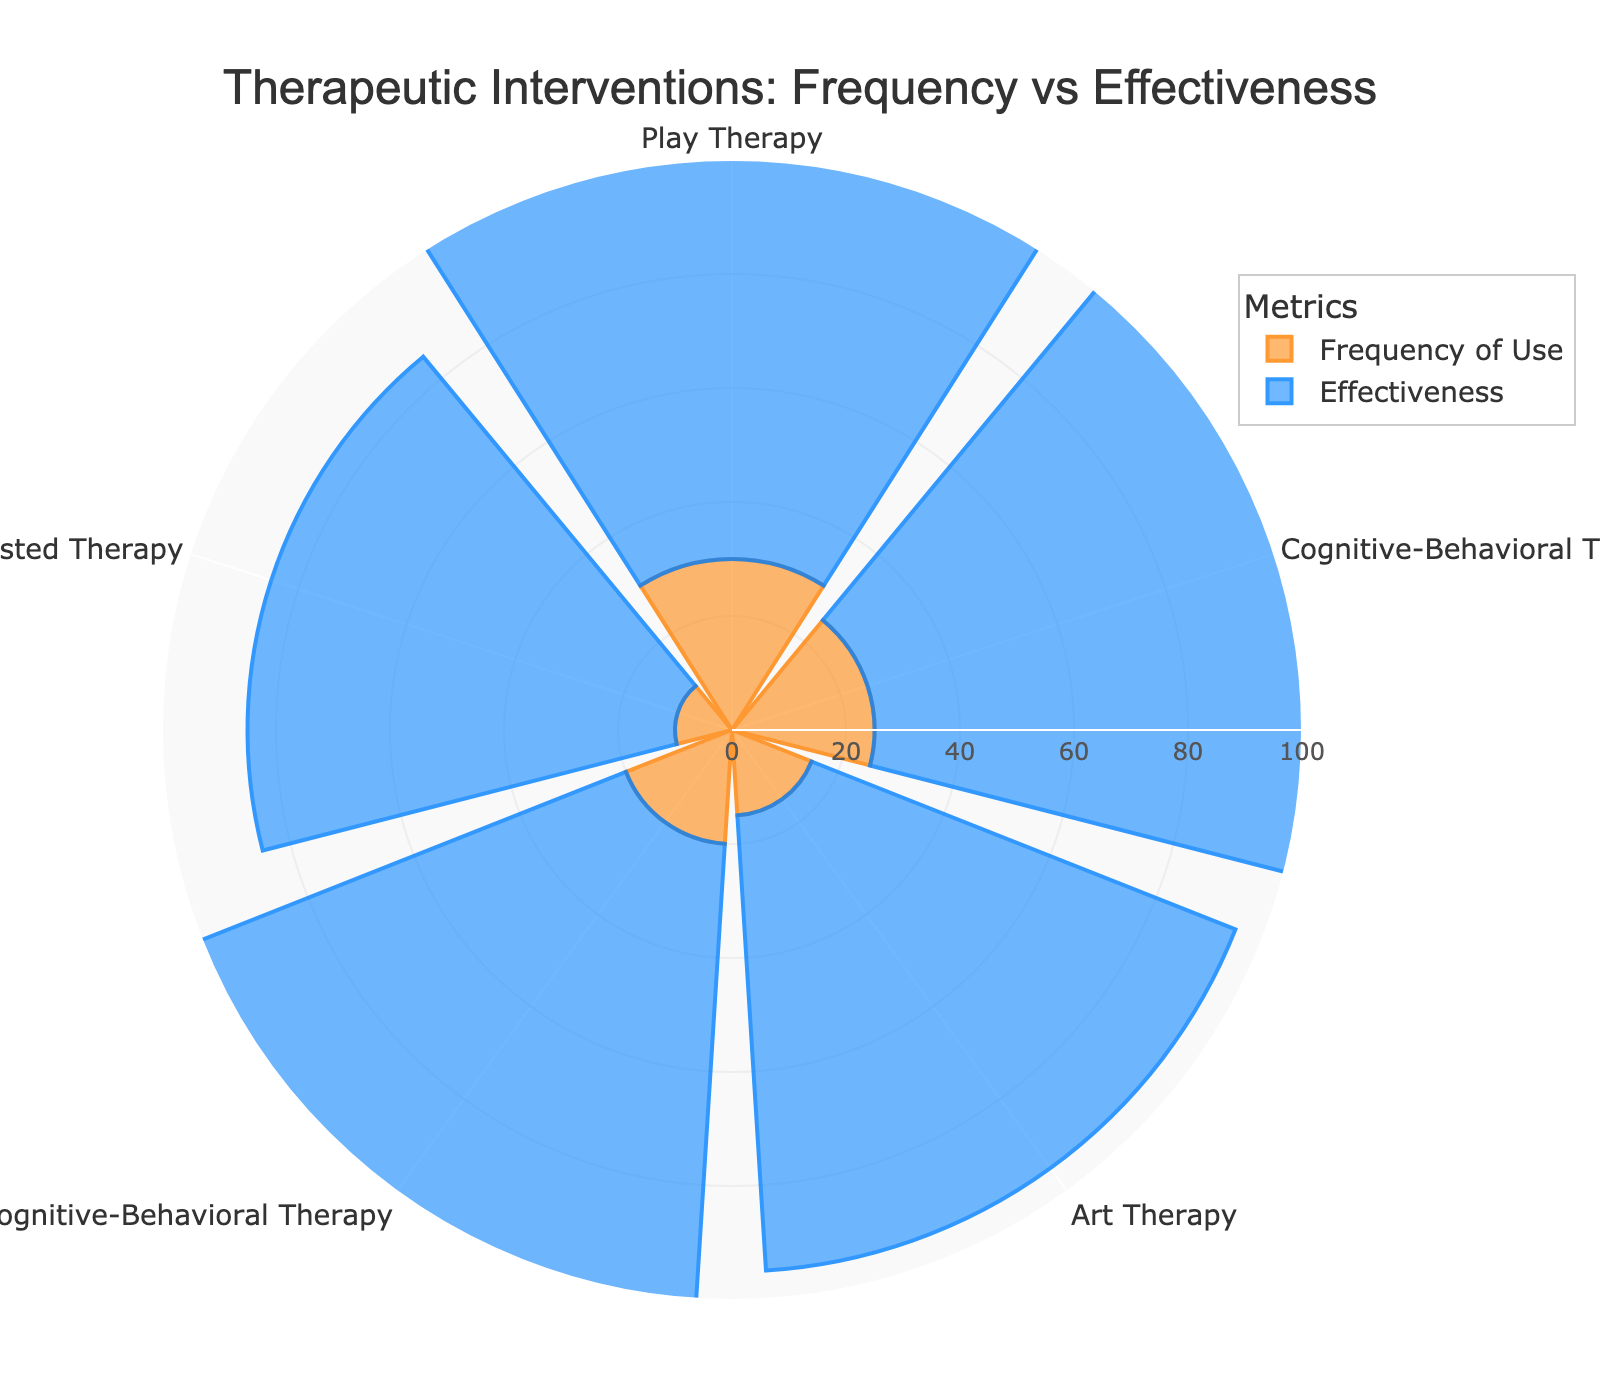What is the most frequently used therapeutic intervention? The bar with the largest radial distance in the "Frequency of Use" category represents Play Therapy, indicating it is the most frequently used intervention.
Answer: Play Therapy Which intervention has the highest effectiveness? The bar with the largest radial distance in the "Effectiveness" category represents Trauma-Focused Cognitive-Behavioral Therapy, indicating it has the highest effectiveness.
Answer: Trauma-Focused Cognitive-Behavioral Therapy What is the least frequently used therapeutic intervention? The shortest bar in the "Frequency of Use" category represents Animal-Assisted Therapy, indicating it is the least frequently used intervention.
Answer: Animal-Assisted Therapy Which two interventions have the same frequency of use? By comparing the radial distances of bars in the "Frequency of Use" category, we can see that Trauma-Focused Cognitive-Behavioral Therapy and Cognitive-Behavioral Therapy both have the same radial distance, indicating they have equal frequency of use.
Answer: Trauma-Focused Cognitive-Behavioral Therapy and Cognitive-Behavioral Therapy How much more effective is Cognitive-Behavioral Therapy compared to Animal-Assisted Therapy? The effectiveness of Cognitive-Behavioral Therapy is 90 and the effectiveness of Animal-Assisted Therapy is 75. The difference in effectiveness is 90 - 75 = 15.
Answer: 15 Which intervention has a higher effectiveness than Play Therapy but a lower frequency of use? Trauma-Focused Cognitive-Behavioral Therapy has an effectiveness of 95, which is higher than Play Therapy's 85, and a lower frequency of 20 compared to Play Therapy's 30.
Answer: Trauma-Focused Cognitive-Behavioral Therapy What is the average effectiveness of all interventions? The effectiveness values are 85, 90, 80, 95, and 75. Summing these gives 85 + 90 + 80 + 95 + 75 = 425. Dividing by the number of interventions (5) gives 425 / 5 = 85.
Answer: 85 Between Art Therapy and Animal-Assisted Therapy, which is more frequently used and by how much? Art Therapy has a frequency of 15, whereas Animal-Assisted Therapy has a frequency of 10. The difference is 15 - 10 = 5, indicating Art Therapy is more frequently used by 5.
Answer: Art Therapy by 5 Which intervention has both lower frequency and effectiveness than Play Therapy? Comparing the bars, Animal-Assisted Therapy has both a lower frequency (10) and effectiveness (75) than Play Therapy (frequency 30, effectiveness 85).
Answer: Animal-Assisted Therapy Considering only the top two most effective interventions, what is their average frequency of use? The top two most effective interventions are Trauma-Focused Cognitive-Behavioral Therapy (95) and Cognitive-Behavioral Therapy (90). Their frequencies are 20 and 25, respectively. The average frequency is (20 + 25) / 2 = 22.5.
Answer: 22.5 